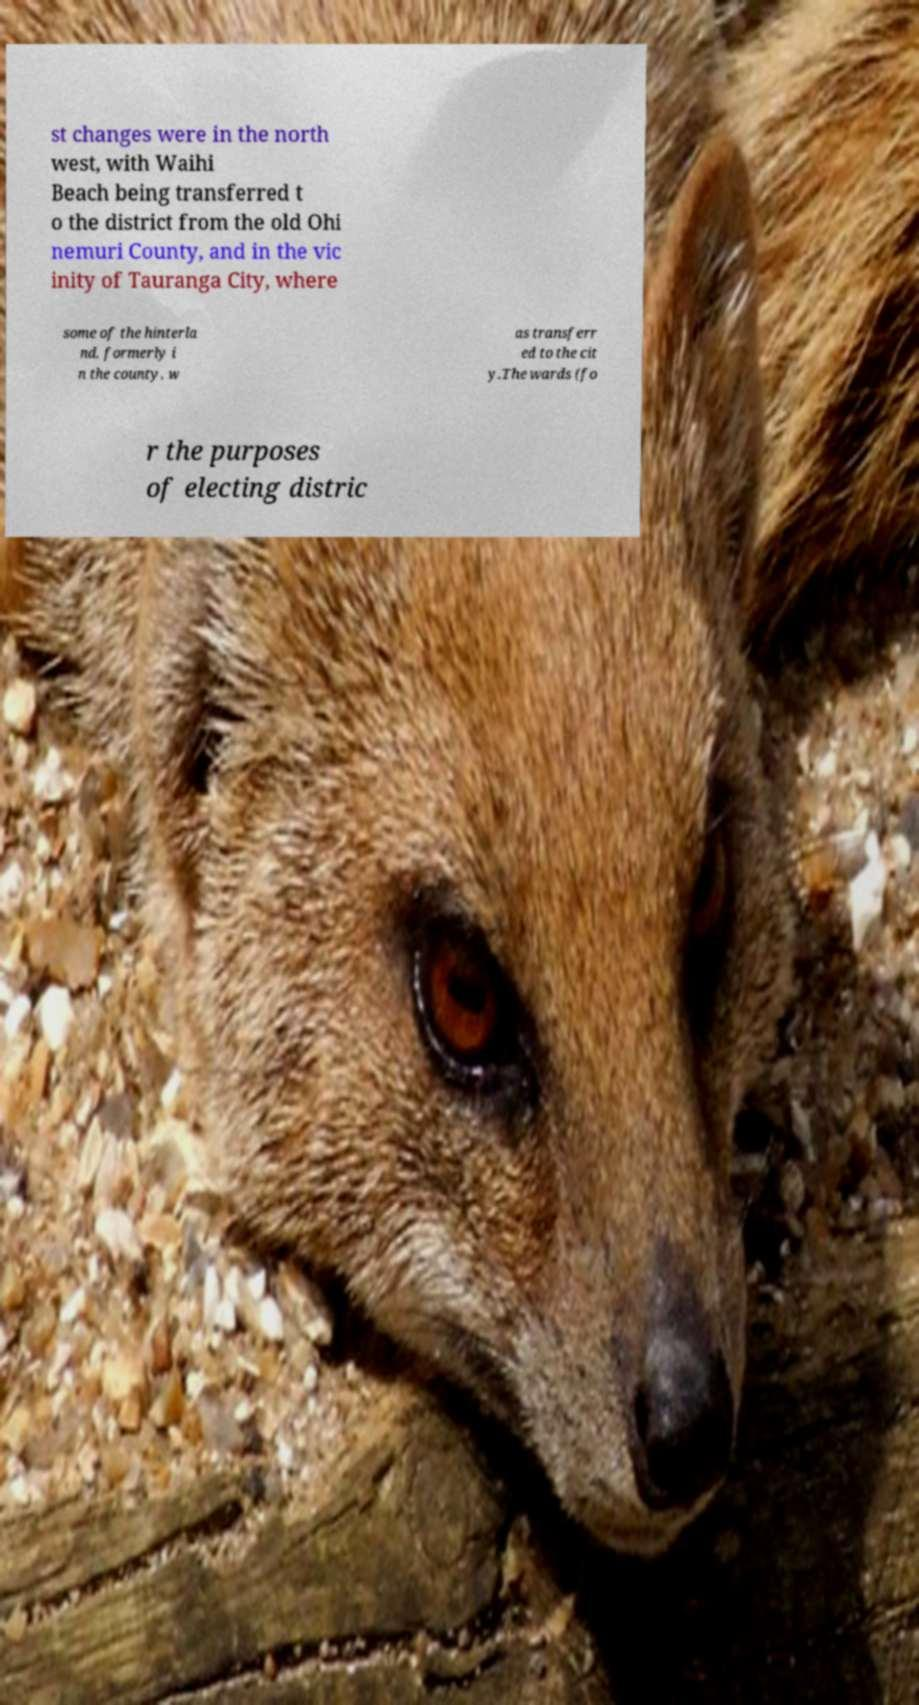There's text embedded in this image that I need extracted. Can you transcribe it verbatim? st changes were in the north west, with Waihi Beach being transferred t o the district from the old Ohi nemuri County, and in the vic inity of Tauranga City, where some of the hinterla nd, formerly i n the county, w as transferr ed to the cit y.The wards (fo r the purposes of electing distric 